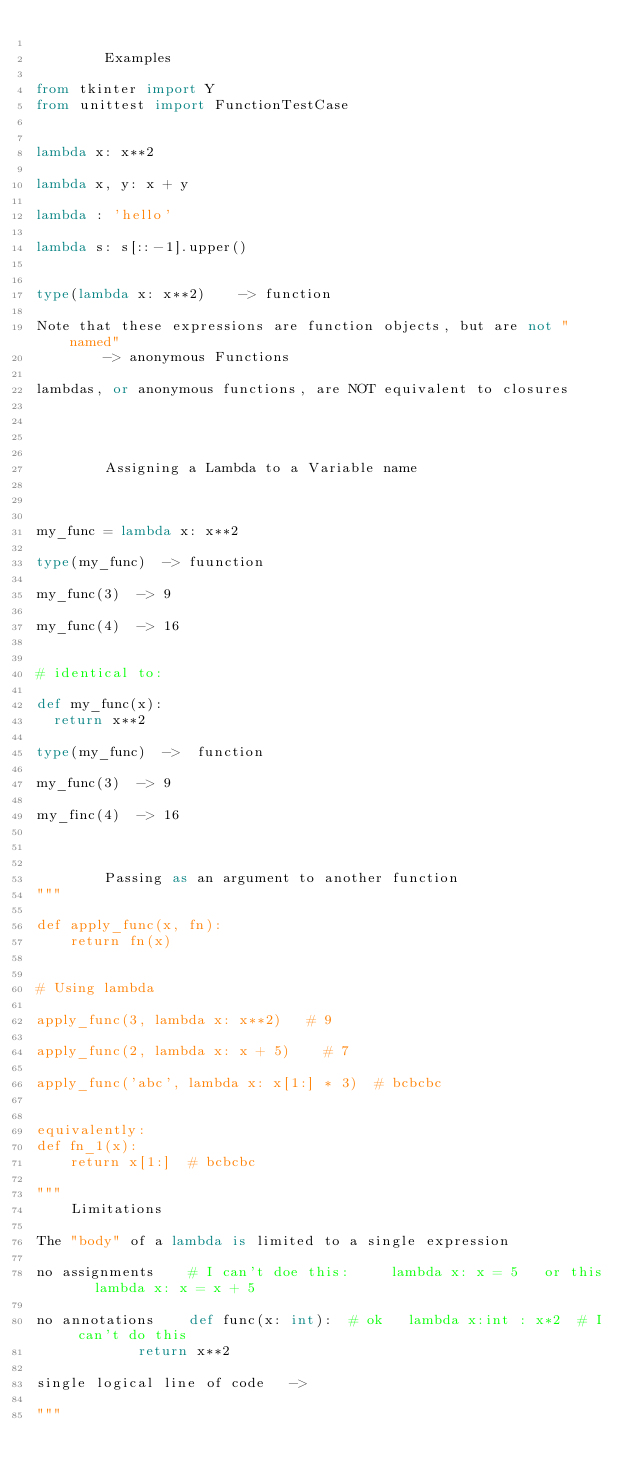<code> <loc_0><loc_0><loc_500><loc_500><_Python_>
        Examples

from tkinter import Y
from unittest import FunctionTestCase


lambda x: x**2

lambda x, y: x + y

lambda : 'hello'

lambda s: s[::-1].upper()


type(lambda x: x**2)    -> function

Note that these expressions are function objects, but are not "named"
        -> anonymous Functions

lambdas, or anonymous functions, are NOT equivalent to closures




        Assigning a Lambda to a Variable name



my_func = lambda x: x**2

type(my_func)  -> fuunction

my_func(3)  -> 9

my_func(4)  -> 16


# identical to:

def my_func(x):
	return x**2

type(my_func)  ->  function

my_func(3)  -> 9

my_finc(4)  -> 16



        Passing as an argument to another function
"""

def apply_func(x, fn):
    return fn(x)


# Using lambda

apply_func(3, lambda x: x**2)		# 9

apply_func(2, lambda x: x + 5)		# 7

apply_func('abc', lambda x: x[1:] * 3)	# bcbcbc


equivalently:
def fn_1(x):
    return x[1:]  # bcbcbc

"""
		Limitations

The "body" of a lambda is limited to a single expression

no assignments		# I can't doe this: 		lambda x: x = 5		or this		lambda x: x = x + 5

no annotations		def func(x: int):  # ok		lambda x:int : x*2	# I can't do this
						return x**2

single logical line of code		-> 

"""

</code> 